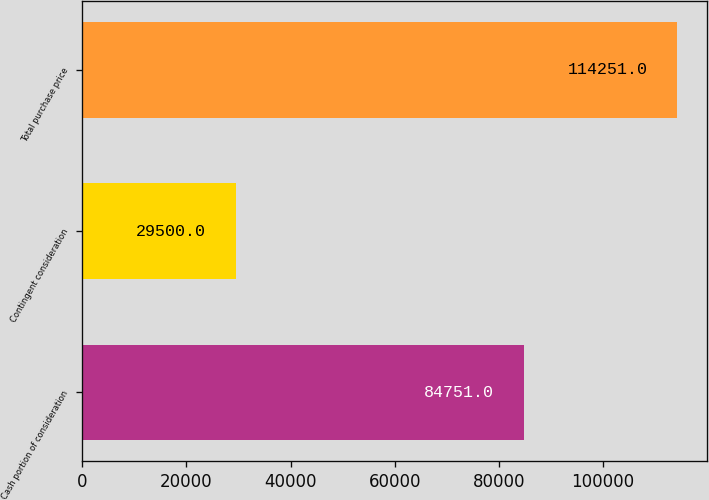Convert chart to OTSL. <chart><loc_0><loc_0><loc_500><loc_500><bar_chart><fcel>Cash portion of consideration<fcel>Contingent consideration<fcel>Total purchase price<nl><fcel>84751<fcel>29500<fcel>114251<nl></chart> 